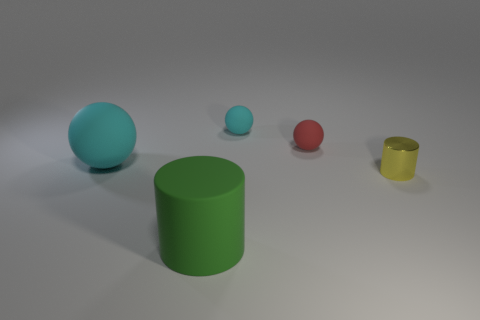Is the material of the big object in front of the yellow metallic cylinder the same as the tiny cylinder?
Make the answer very short. No. What is the shape of the yellow object?
Make the answer very short. Cylinder. How many large cyan matte things are in front of the large rubber object behind the tiny yellow shiny object that is on the right side of the small red object?
Keep it short and to the point. 0. What number of other things are made of the same material as the large green thing?
Provide a short and direct response. 3. What is the material of the yellow cylinder that is the same size as the red ball?
Ensure brevity in your answer.  Metal. Do the big rubber object behind the yellow metal cylinder and the small ball that is behind the red sphere have the same color?
Make the answer very short. Yes. Is there a red object of the same shape as the tiny cyan rubber object?
Your answer should be very brief. Yes. What is the shape of the cyan rubber object that is the same size as the red matte ball?
Offer a terse response. Sphere. What number of small objects are the same color as the large sphere?
Ensure brevity in your answer.  1. What size is the cyan matte sphere that is to the right of the green matte cylinder?
Your response must be concise. Small. 